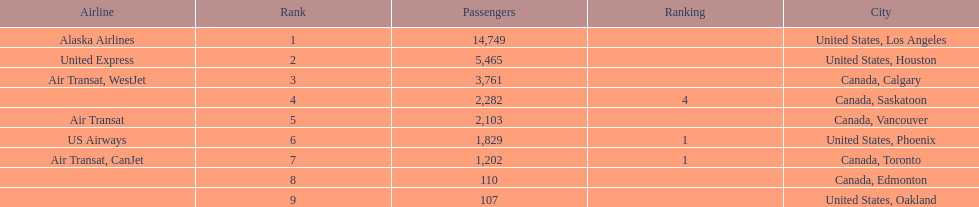What numbers are in the passengers column? 14,749, 5,465, 3,761, 2,282, 2,103, 1,829, 1,202, 110, 107. Which number is the lowest number in the passengers column? 107. What city is associated with this number? United States, Oakland. 